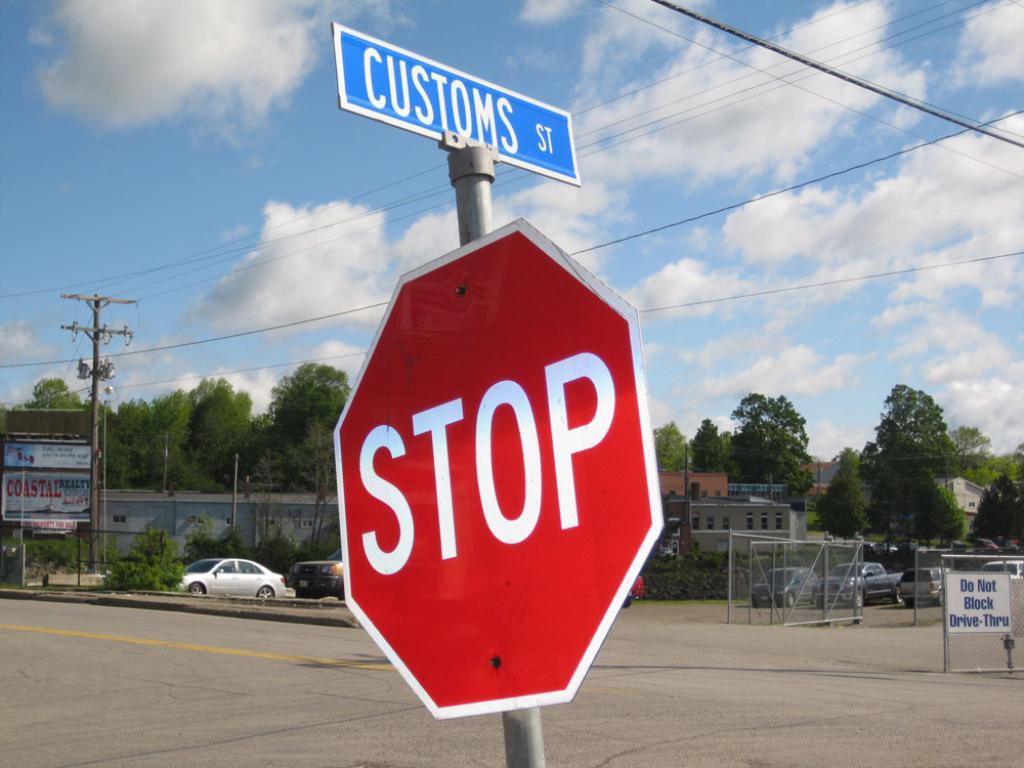<image>
Create a compact narrative representing the image presented. The stop sign is located on Customs St. 